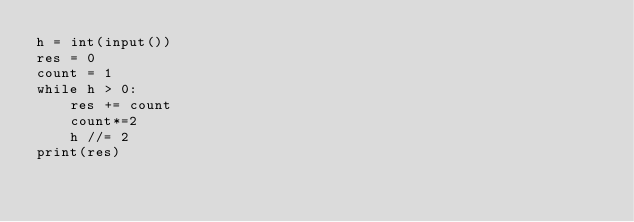Convert code to text. <code><loc_0><loc_0><loc_500><loc_500><_Python_>h = int(input())
res = 0
count = 1
while h > 0:
    res += count
    count*=2
    h //= 2
print(res)</code> 